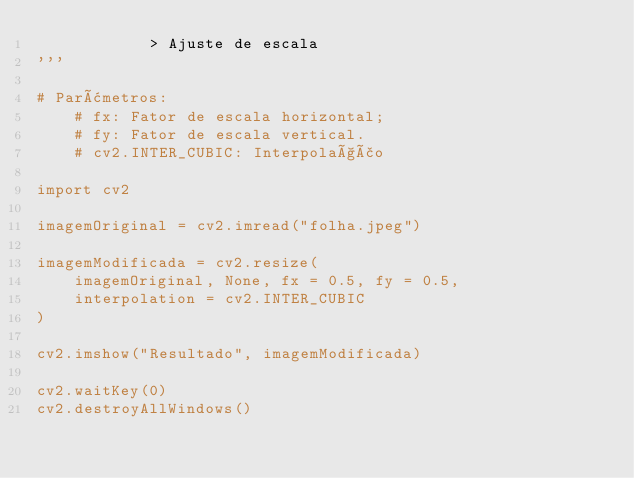Convert code to text. <code><loc_0><loc_0><loc_500><loc_500><_Python_>            > Ajuste de escala
'''

# Parâmetros:
    # fx: Fator de escala horizontal;
    # fy: Fator de escala vertical.
    # cv2.INTER_CUBIC: Interpolação

import cv2

imagemOriginal = cv2.imread("folha.jpeg")

imagemModificada = cv2.resize(
    imagemOriginal, None, fx = 0.5, fy = 0.5,
    interpolation = cv2.INTER_CUBIC
)

cv2.imshow("Resultado", imagemModificada)

cv2.waitKey(0)
cv2.destroyAllWindows()
</code> 